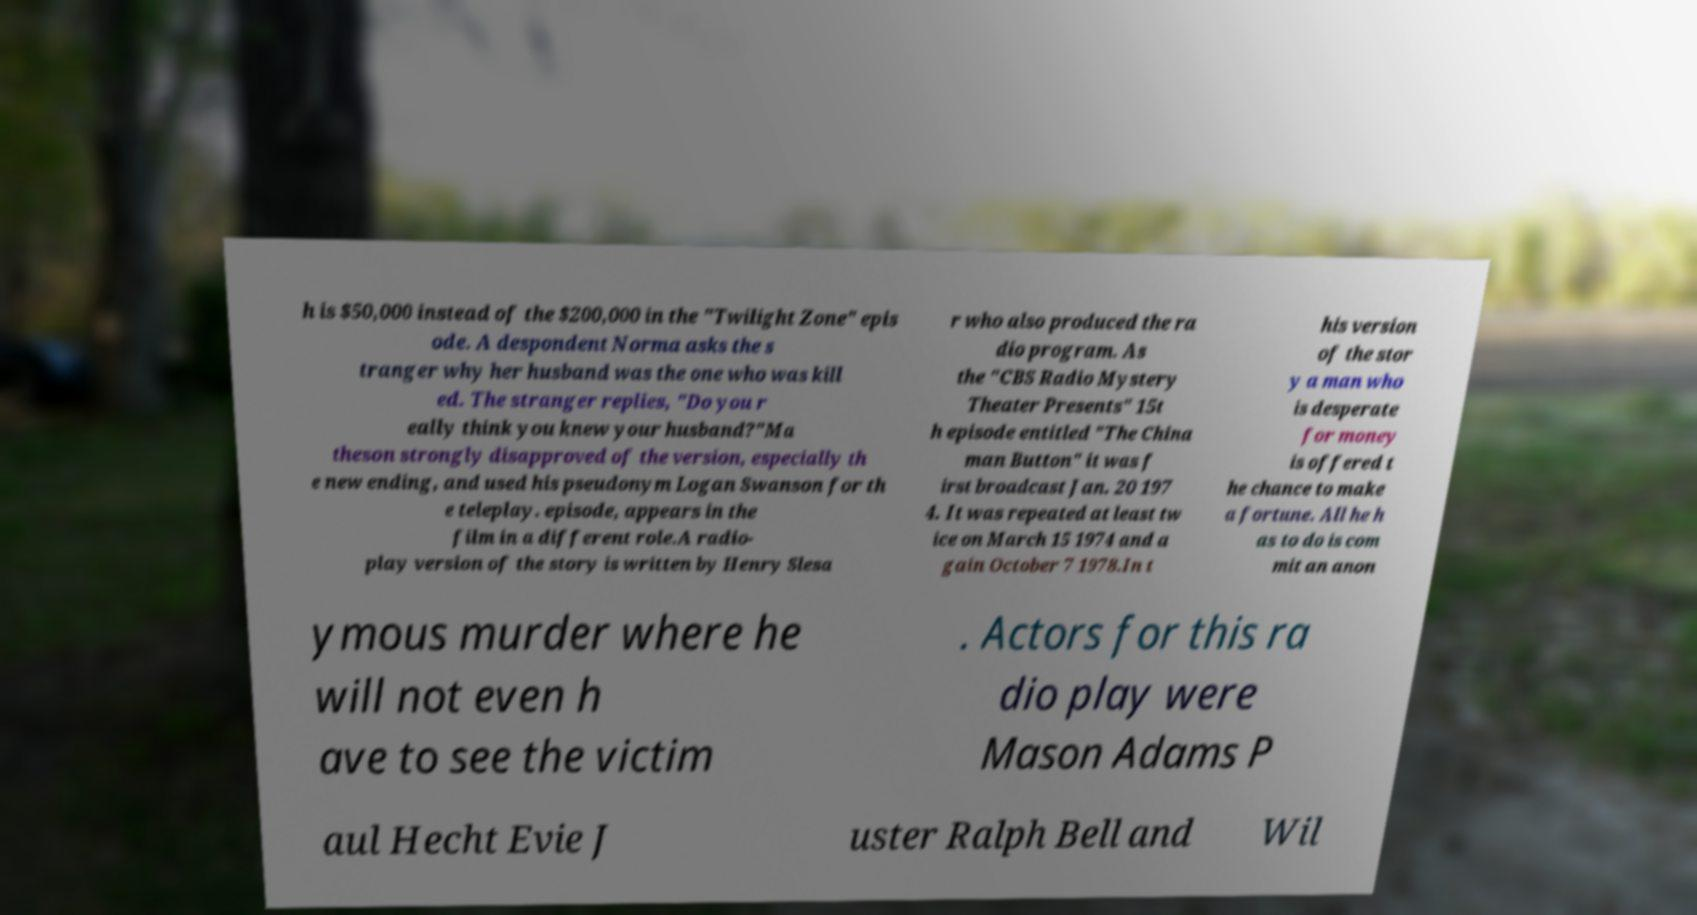Please read and relay the text visible in this image. What does it say? h is $50,000 instead of the $200,000 in the "Twilight Zone" epis ode. A despondent Norma asks the s tranger why her husband was the one who was kill ed. The stranger replies, "Do you r eally think you knew your husband?"Ma theson strongly disapproved of the version, especially th e new ending, and used his pseudonym Logan Swanson for th e teleplay. episode, appears in the film in a different role.A radio- play version of the story is written by Henry Slesa r who also produced the ra dio program. As the "CBS Radio Mystery Theater Presents" 15t h episode entitled "The China man Button" it was f irst broadcast Jan. 20 197 4. It was repeated at least tw ice on March 15 1974 and a gain October 7 1978.In t his version of the stor y a man who is desperate for money is offered t he chance to make a fortune. All he h as to do is com mit an anon ymous murder where he will not even h ave to see the victim . Actors for this ra dio play were Mason Adams P aul Hecht Evie J uster Ralph Bell and Wil 